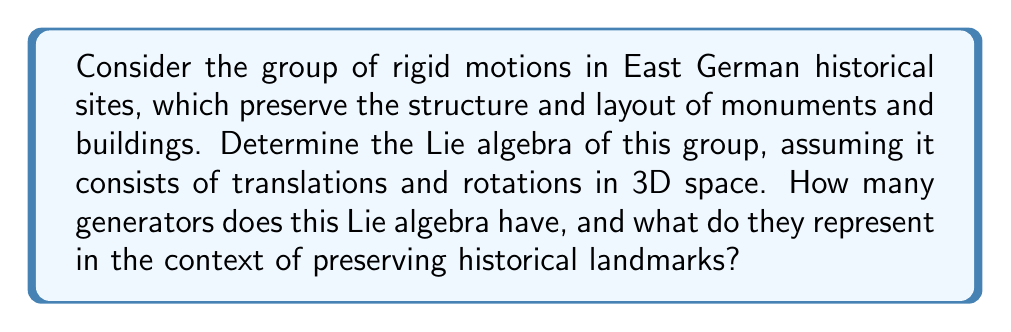Teach me how to tackle this problem. To solve this problem, we need to consider the following steps:

1. Identify the group of rigid motions:
   The group of rigid motions in 3D space is the Special Euclidean group SE(3), which combines rotations (SO(3)) and translations in 3D space.

2. Determine the Lie algebra of SE(3):
   The Lie algebra of SE(3) is denoted as $\mathfrak{se}(3)$.

3. Analyze the components of $\mathfrak{se}(3)$:
   a) Rotations: The Lie algebra of SO(3) is $\mathfrak{so}(3)$, which has 3 generators corresponding to rotations around the x, y, and z axes.
   b) Translations: There are 3 generators corresponding to translations along the x, y, and z axes.

4. Count the total number of generators:
   The Lie algebra $\mathfrak{se}(3)$ has 6 generators in total: 3 for rotations and 3 for translations.

5. Represent the generators mathematically:
   The generators can be represented as 4x4 matrices:

   Rotations:
   $$R_x = \begin{pmatrix} 0 & 0 & 0 & 0 \\ 0 & 0 & -1 & 0 \\ 0 & 1 & 0 & 0 \\ 0 & 0 & 0 & 0 \end{pmatrix},
   R_y = \begin{pmatrix} 0 & 0 & 1 & 0 \\ 0 & 0 & 0 & 0 \\ -1 & 0 & 0 & 0 \\ 0 & 0 & 0 & 0 \end{pmatrix},
   R_z = \begin{pmatrix} 0 & -1 & 0 & 0 \\ 1 & 0 & 0 & 0 \\ 0 & 0 & 0 & 0 \\ 0 & 0 & 0 & 0 \end{pmatrix}$$

   Translations:
   $$T_x = \begin{pmatrix} 0 & 0 & 0 & 1 \\ 0 & 0 & 0 & 0 \\ 0 & 0 & 0 & 0 \\ 0 & 0 & 0 & 0 \end{pmatrix},
   T_y = \begin{pmatrix} 0 & 0 & 0 & 0 \\ 0 & 0 & 0 & 1 \\ 0 & 0 & 0 & 0 \\ 0 & 0 & 0 & 0 \end{pmatrix},
   T_z = \begin{pmatrix} 0 & 0 & 0 & 0 \\ 0 & 0 & 0 & 0 \\ 0 & 0 & 0 & 1 \\ 0 & 0 & 0 & 0 \end{pmatrix}$$

6. Interpret the generators in the context of preserving historical landmarks:
   - Rotation generators ($R_x$, $R_y$, $R_z$) represent the preservation of orientation and angular relationships between structures.
   - Translation generators ($T_x$, $T_y$, $T_z$) represent the preservation of relative positions and distances between landmarks.

These generators allow for the description of any rigid motion that maintains the spatial relationships and structural integrity of East German historical sites.
Answer: The Lie algebra $\mathfrak{se}(3)$ of the group of rigid motions in East German historical sites has 6 generators. These consist of 3 rotation generators ($R_x$, $R_y$, $R_z$) representing the preservation of orientation, and 3 translation generators ($T_x$, $T_y$, $T_z$) representing the preservation of relative positions between historical landmarks. 